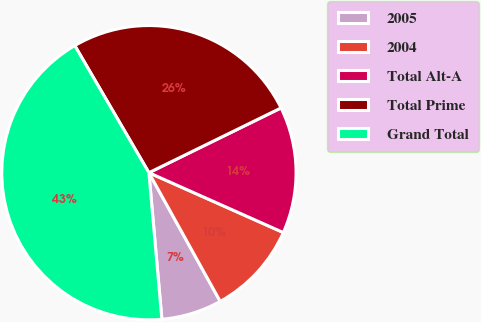<chart> <loc_0><loc_0><loc_500><loc_500><pie_chart><fcel>2005<fcel>2004<fcel>Total Alt-A<fcel>Total Prime<fcel>Grand Total<nl><fcel>6.65%<fcel>10.28%<fcel>13.92%<fcel>26.15%<fcel>43.0%<nl></chart> 